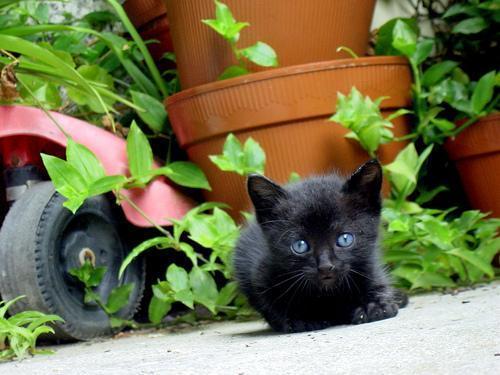How many pots can be seen?
Give a very brief answer. 3. How many potted plants can be seen?
Give a very brief answer. 4. How many cats are there?
Give a very brief answer. 1. 